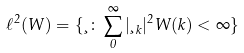Convert formula to latex. <formula><loc_0><loc_0><loc_500><loc_500>\ell ^ { 2 } ( W ) = \{ \xi \colon \sum _ { 0 } ^ { \infty } | \xi _ { k } | ^ { 2 } W ( k ) < \infty \}</formula> 